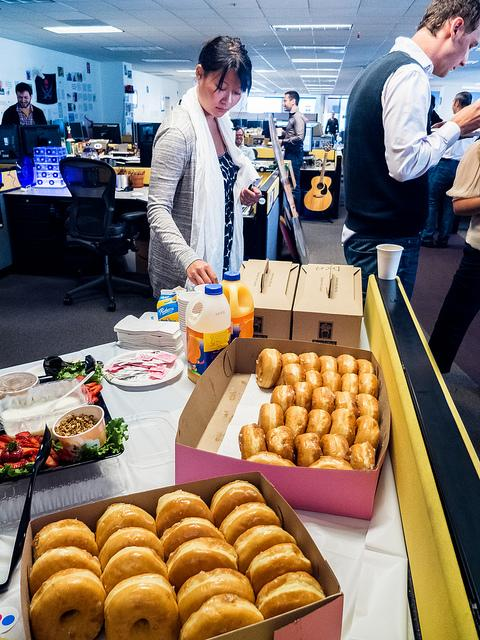What setting does this seem to be? office 